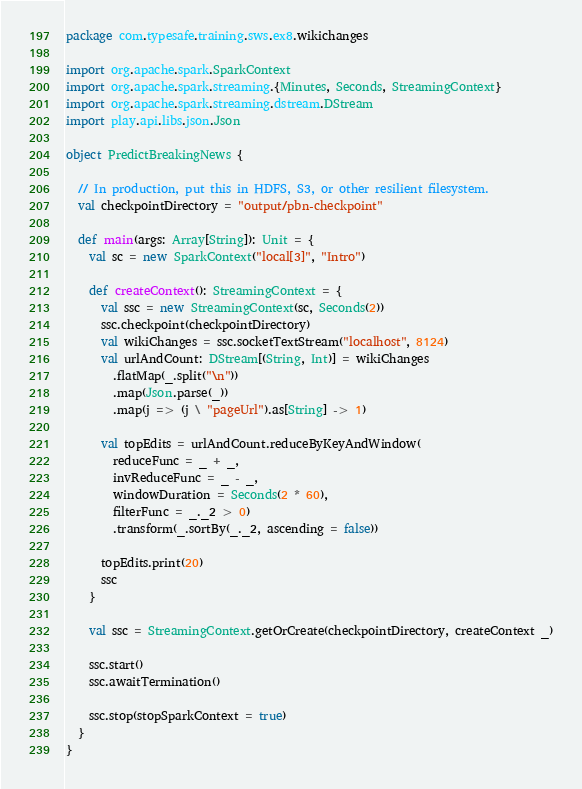Convert code to text. <code><loc_0><loc_0><loc_500><loc_500><_Scala_>package com.typesafe.training.sws.ex8.wikichanges

import org.apache.spark.SparkContext
import org.apache.spark.streaming.{Minutes, Seconds, StreamingContext}
import org.apache.spark.streaming.dstream.DStream
import play.api.libs.json.Json

object PredictBreakingNews {

  // In production, put this in HDFS, S3, or other resilient filesystem.
  val checkpointDirectory = "output/pbn-checkpoint"

  def main(args: Array[String]): Unit = {
    val sc = new SparkContext("local[3]", "Intro")

    def createContext(): StreamingContext = {
      val ssc = new StreamingContext(sc, Seconds(2))
      ssc.checkpoint(checkpointDirectory)
      val wikiChanges = ssc.socketTextStream("localhost", 8124)
      val urlAndCount: DStream[(String, Int)] = wikiChanges
        .flatMap(_.split("\n"))
        .map(Json.parse(_))
        .map(j => (j \ "pageUrl").as[String] -> 1)

      val topEdits = urlAndCount.reduceByKeyAndWindow(
        reduceFunc = _ + _,
        invReduceFunc = _ - _,
        windowDuration = Seconds(2 * 60),
        filterFunc = _._2 > 0)
        .transform(_.sortBy(_._2, ascending = false))

      topEdits.print(20)
      ssc
    }

    val ssc = StreamingContext.getOrCreate(checkpointDirectory, createContext _)

    ssc.start()
    ssc.awaitTermination()

    ssc.stop(stopSparkContext = true)
  }
}
</code> 